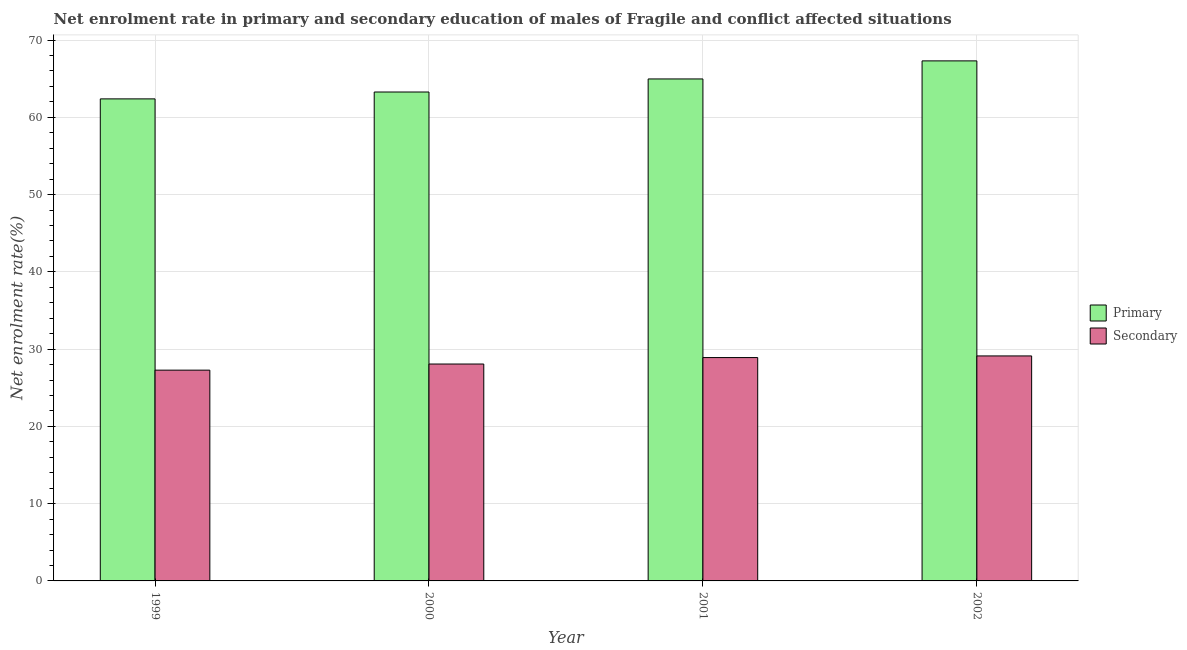How many groups of bars are there?
Offer a terse response. 4. Are the number of bars per tick equal to the number of legend labels?
Give a very brief answer. Yes. How many bars are there on the 4th tick from the left?
Your answer should be very brief. 2. In how many cases, is the number of bars for a given year not equal to the number of legend labels?
Provide a succinct answer. 0. What is the enrollment rate in primary education in 1999?
Your answer should be very brief. 62.38. Across all years, what is the maximum enrollment rate in primary education?
Ensure brevity in your answer.  67.3. Across all years, what is the minimum enrollment rate in secondary education?
Keep it short and to the point. 27.28. In which year was the enrollment rate in secondary education maximum?
Ensure brevity in your answer.  2002. What is the total enrollment rate in secondary education in the graph?
Keep it short and to the point. 113.37. What is the difference between the enrollment rate in secondary education in 2000 and that in 2002?
Provide a succinct answer. -1.05. What is the difference between the enrollment rate in secondary education in 2000 and the enrollment rate in primary education in 2002?
Offer a terse response. -1.05. What is the average enrollment rate in secondary education per year?
Make the answer very short. 28.34. What is the ratio of the enrollment rate in primary education in 2000 to that in 2001?
Provide a succinct answer. 0.97. What is the difference between the highest and the second highest enrollment rate in primary education?
Provide a short and direct response. 2.34. What is the difference between the highest and the lowest enrollment rate in secondary education?
Make the answer very short. 1.84. Is the sum of the enrollment rate in secondary education in 2000 and 2001 greater than the maximum enrollment rate in primary education across all years?
Your answer should be compact. Yes. What does the 2nd bar from the left in 2001 represents?
Provide a succinct answer. Secondary. What does the 2nd bar from the right in 2001 represents?
Provide a succinct answer. Primary. What is the difference between two consecutive major ticks on the Y-axis?
Ensure brevity in your answer.  10. Are the values on the major ticks of Y-axis written in scientific E-notation?
Make the answer very short. No. Does the graph contain any zero values?
Offer a terse response. No. What is the title of the graph?
Provide a succinct answer. Net enrolment rate in primary and secondary education of males of Fragile and conflict affected situations. What is the label or title of the X-axis?
Provide a short and direct response. Year. What is the label or title of the Y-axis?
Your response must be concise. Net enrolment rate(%). What is the Net enrolment rate(%) in Primary in 1999?
Give a very brief answer. 62.38. What is the Net enrolment rate(%) in Secondary in 1999?
Provide a short and direct response. 27.28. What is the Net enrolment rate(%) in Primary in 2000?
Offer a terse response. 63.27. What is the Net enrolment rate(%) in Secondary in 2000?
Offer a very short reply. 28.07. What is the Net enrolment rate(%) of Primary in 2001?
Provide a succinct answer. 64.96. What is the Net enrolment rate(%) in Secondary in 2001?
Offer a terse response. 28.9. What is the Net enrolment rate(%) of Primary in 2002?
Keep it short and to the point. 67.3. What is the Net enrolment rate(%) of Secondary in 2002?
Provide a short and direct response. 29.12. Across all years, what is the maximum Net enrolment rate(%) in Primary?
Keep it short and to the point. 67.3. Across all years, what is the maximum Net enrolment rate(%) of Secondary?
Offer a very short reply. 29.12. Across all years, what is the minimum Net enrolment rate(%) in Primary?
Offer a terse response. 62.38. Across all years, what is the minimum Net enrolment rate(%) of Secondary?
Provide a short and direct response. 27.28. What is the total Net enrolment rate(%) of Primary in the graph?
Provide a short and direct response. 257.91. What is the total Net enrolment rate(%) in Secondary in the graph?
Keep it short and to the point. 113.37. What is the difference between the Net enrolment rate(%) of Primary in 1999 and that in 2000?
Offer a very short reply. -0.89. What is the difference between the Net enrolment rate(%) of Secondary in 1999 and that in 2000?
Provide a short and direct response. -0.79. What is the difference between the Net enrolment rate(%) of Primary in 1999 and that in 2001?
Provide a succinct answer. -2.58. What is the difference between the Net enrolment rate(%) of Secondary in 1999 and that in 2001?
Provide a succinct answer. -1.63. What is the difference between the Net enrolment rate(%) of Primary in 1999 and that in 2002?
Your answer should be very brief. -4.92. What is the difference between the Net enrolment rate(%) of Secondary in 1999 and that in 2002?
Your answer should be compact. -1.84. What is the difference between the Net enrolment rate(%) in Primary in 2000 and that in 2001?
Make the answer very short. -1.69. What is the difference between the Net enrolment rate(%) in Secondary in 2000 and that in 2001?
Provide a short and direct response. -0.84. What is the difference between the Net enrolment rate(%) in Primary in 2000 and that in 2002?
Provide a short and direct response. -4.03. What is the difference between the Net enrolment rate(%) in Secondary in 2000 and that in 2002?
Provide a short and direct response. -1.05. What is the difference between the Net enrolment rate(%) of Primary in 2001 and that in 2002?
Your answer should be compact. -2.34. What is the difference between the Net enrolment rate(%) of Secondary in 2001 and that in 2002?
Your response must be concise. -0.21. What is the difference between the Net enrolment rate(%) of Primary in 1999 and the Net enrolment rate(%) of Secondary in 2000?
Make the answer very short. 34.31. What is the difference between the Net enrolment rate(%) of Primary in 1999 and the Net enrolment rate(%) of Secondary in 2001?
Make the answer very short. 33.48. What is the difference between the Net enrolment rate(%) of Primary in 1999 and the Net enrolment rate(%) of Secondary in 2002?
Keep it short and to the point. 33.26. What is the difference between the Net enrolment rate(%) in Primary in 2000 and the Net enrolment rate(%) in Secondary in 2001?
Keep it short and to the point. 34.37. What is the difference between the Net enrolment rate(%) of Primary in 2000 and the Net enrolment rate(%) of Secondary in 2002?
Your response must be concise. 34.15. What is the difference between the Net enrolment rate(%) in Primary in 2001 and the Net enrolment rate(%) in Secondary in 2002?
Offer a very short reply. 35.84. What is the average Net enrolment rate(%) of Primary per year?
Your answer should be compact. 64.48. What is the average Net enrolment rate(%) in Secondary per year?
Provide a short and direct response. 28.34. In the year 1999, what is the difference between the Net enrolment rate(%) in Primary and Net enrolment rate(%) in Secondary?
Your answer should be very brief. 35.11. In the year 2000, what is the difference between the Net enrolment rate(%) in Primary and Net enrolment rate(%) in Secondary?
Ensure brevity in your answer.  35.2. In the year 2001, what is the difference between the Net enrolment rate(%) in Primary and Net enrolment rate(%) in Secondary?
Ensure brevity in your answer.  36.06. In the year 2002, what is the difference between the Net enrolment rate(%) of Primary and Net enrolment rate(%) of Secondary?
Your answer should be very brief. 38.18. What is the ratio of the Net enrolment rate(%) in Primary in 1999 to that in 2000?
Give a very brief answer. 0.99. What is the ratio of the Net enrolment rate(%) of Secondary in 1999 to that in 2000?
Make the answer very short. 0.97. What is the ratio of the Net enrolment rate(%) of Primary in 1999 to that in 2001?
Ensure brevity in your answer.  0.96. What is the ratio of the Net enrolment rate(%) of Secondary in 1999 to that in 2001?
Provide a succinct answer. 0.94. What is the ratio of the Net enrolment rate(%) in Primary in 1999 to that in 2002?
Keep it short and to the point. 0.93. What is the ratio of the Net enrolment rate(%) in Secondary in 1999 to that in 2002?
Your answer should be compact. 0.94. What is the ratio of the Net enrolment rate(%) in Secondary in 2000 to that in 2001?
Make the answer very short. 0.97. What is the ratio of the Net enrolment rate(%) of Primary in 2000 to that in 2002?
Provide a short and direct response. 0.94. What is the ratio of the Net enrolment rate(%) in Primary in 2001 to that in 2002?
Keep it short and to the point. 0.97. What is the difference between the highest and the second highest Net enrolment rate(%) in Primary?
Ensure brevity in your answer.  2.34. What is the difference between the highest and the second highest Net enrolment rate(%) of Secondary?
Offer a very short reply. 0.21. What is the difference between the highest and the lowest Net enrolment rate(%) in Primary?
Your answer should be compact. 4.92. What is the difference between the highest and the lowest Net enrolment rate(%) in Secondary?
Give a very brief answer. 1.84. 